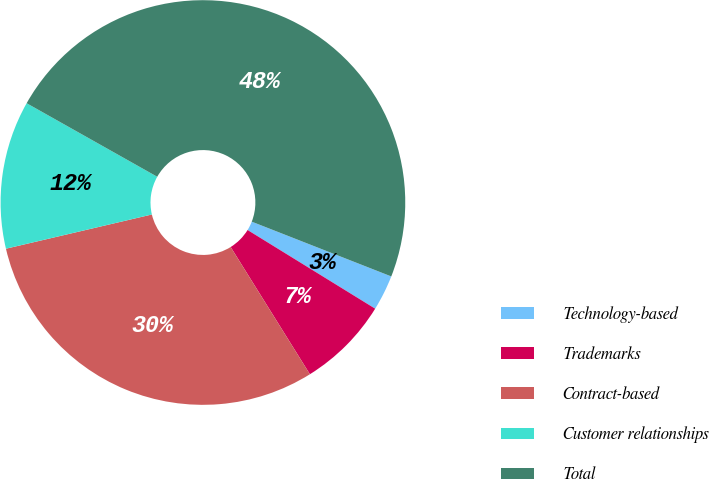<chart> <loc_0><loc_0><loc_500><loc_500><pie_chart><fcel>Technology-based<fcel>Trademarks<fcel>Contract-based<fcel>Customer relationships<fcel>Total<nl><fcel>2.84%<fcel>7.34%<fcel>30.2%<fcel>11.83%<fcel>47.79%<nl></chart> 